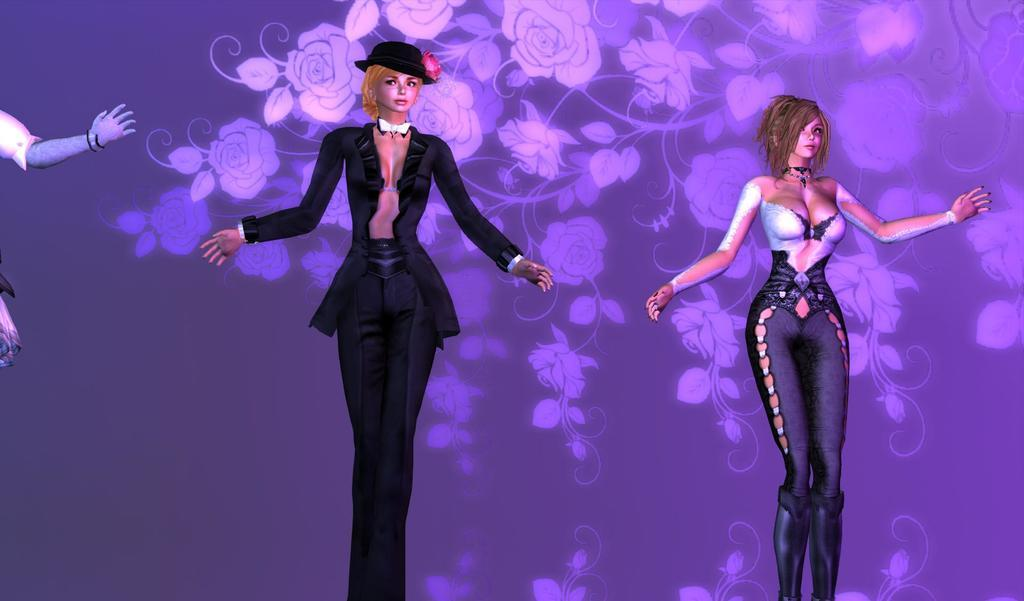What is the main subject in the center of the image? There are dolls in the center of the image. What else can be seen in the background of the image? There is an art piece visible in the background of the image. What type of bone is being offered to the dolls in the image? There is no bone present in the image, and the dolls are not interacting with any objects. 